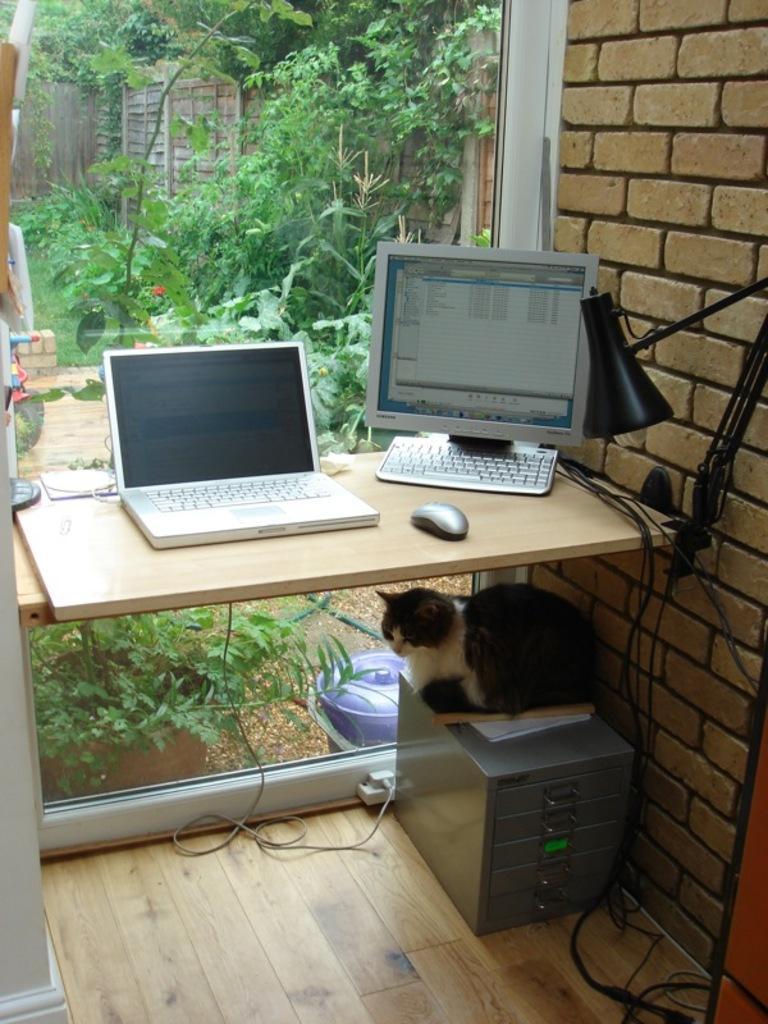Could you give a brief overview of what you see in this image? There is a laptop and a computer placed on the table. under the table there is a cat, sitting on a box. In the background, there is a tree and a wall here. 